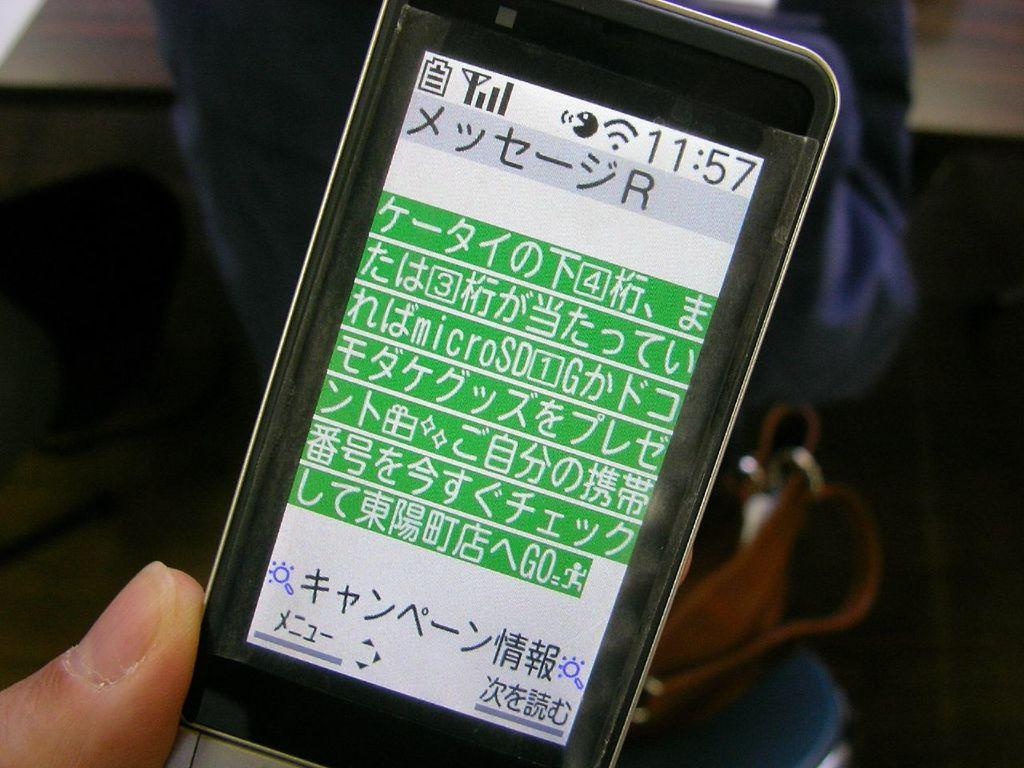What is the person in the image holding? The person in the image is holding a mobile phone. Can you describe the person's location in relation to other objects in the image? The person is standing near a table in the image. What type of agreement is being discussed by the group in the image? There is no group present in the image, and therefore no discussion or agreement can be observed. 